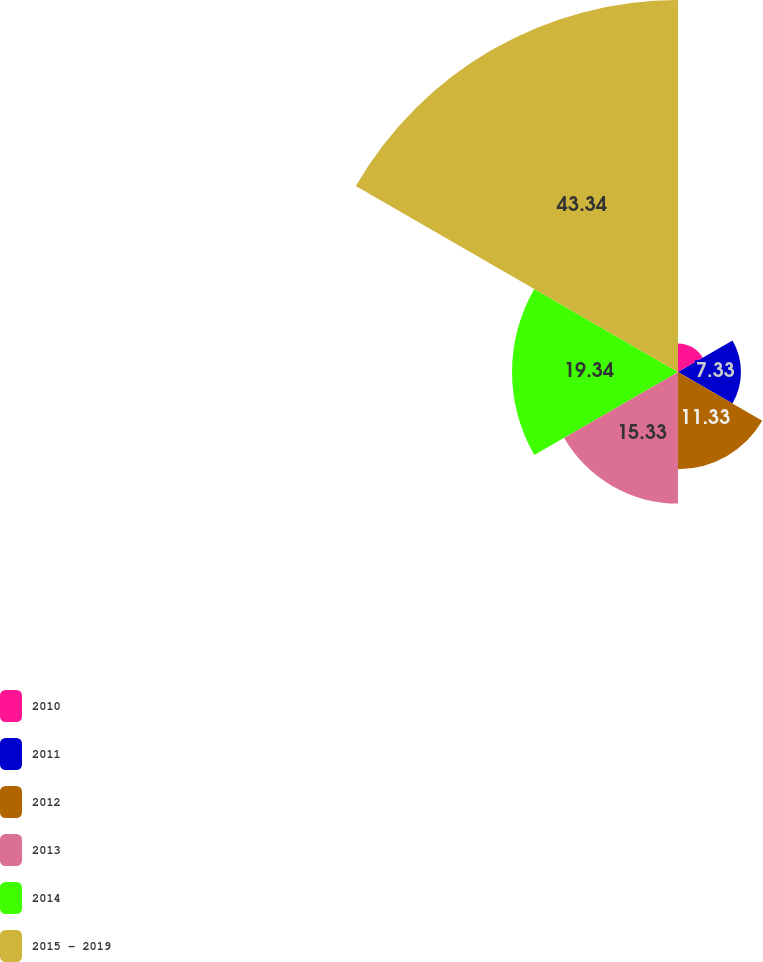Convert chart. <chart><loc_0><loc_0><loc_500><loc_500><pie_chart><fcel>2010<fcel>2011<fcel>2012<fcel>2013<fcel>2014<fcel>2015 - 2019<nl><fcel>3.33%<fcel>7.33%<fcel>11.33%<fcel>15.33%<fcel>19.33%<fcel>43.33%<nl></chart> 